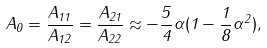Convert formula to latex. <formula><loc_0><loc_0><loc_500><loc_500>A _ { 0 } = \frac { { A } _ { 1 1 } } { { A } _ { 1 2 } } = \frac { { A } _ { 2 1 } } { { A } _ { 2 2 } } \approx - \frac { 5 } { 4 } \alpha ( 1 - \frac { 1 } { 8 } \alpha ^ { 2 } ) ,</formula> 